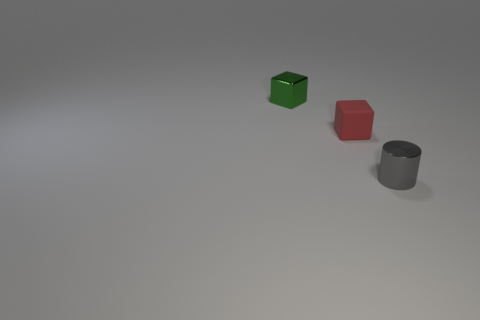Add 3 tiny red rubber balls. How many objects exist? 6 Subtract all cylinders. How many objects are left? 2 Subtract 1 cubes. How many cubes are left? 1 Subtract 0 yellow balls. How many objects are left? 3 Subtract all green blocks. Subtract all yellow cylinders. How many blocks are left? 1 Subtract all small gray shiny objects. Subtract all blocks. How many objects are left? 0 Add 1 rubber objects. How many rubber objects are left? 2 Add 3 gray metal spheres. How many gray metal spheres exist? 3 